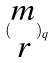<formula> <loc_0><loc_0><loc_500><loc_500>( \begin{matrix} m \\ r \end{matrix} ) _ { q }</formula> 